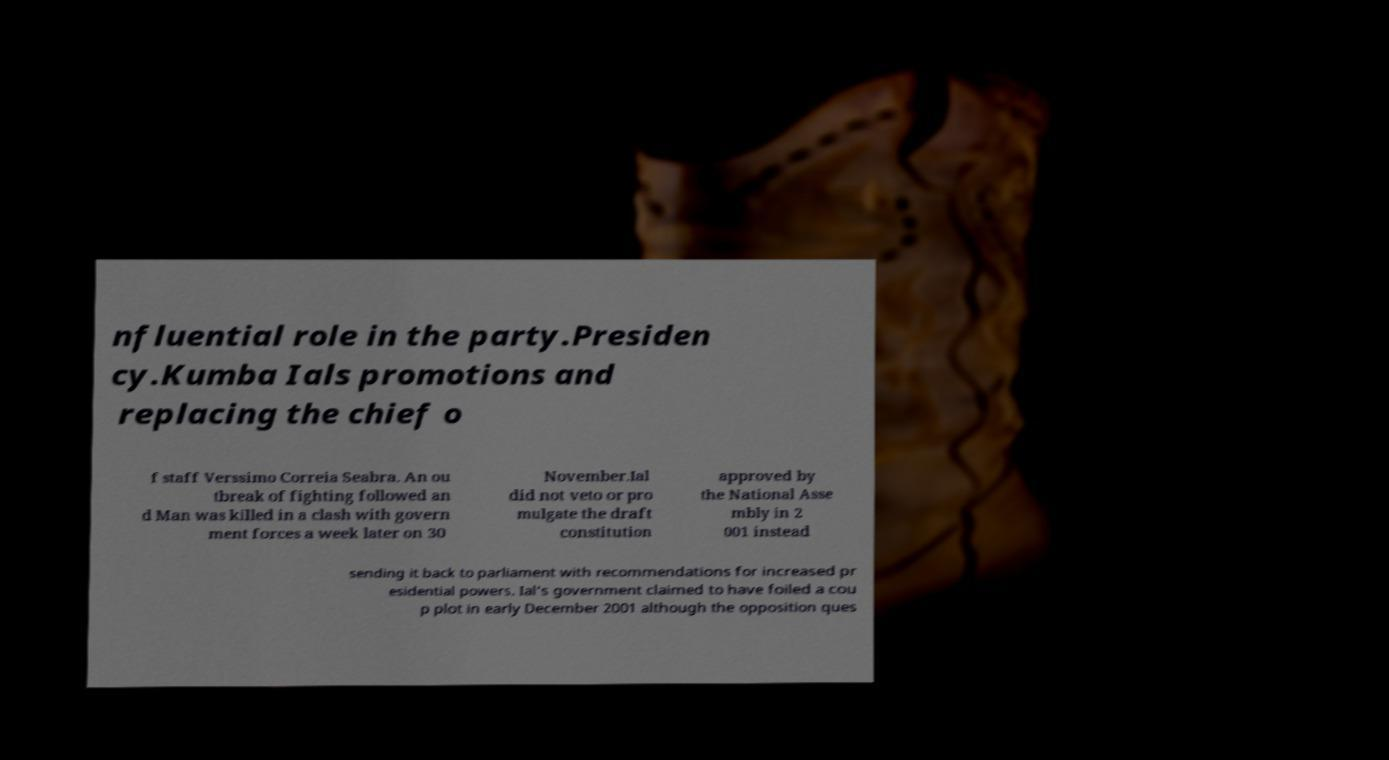What messages or text are displayed in this image? I need them in a readable, typed format. nfluential role in the party.Presiden cy.Kumba Ials promotions and replacing the chief o f staff Verssimo Correia Seabra. An ou tbreak of fighting followed an d Man was killed in a clash with govern ment forces a week later on 30 November.Ial did not veto or pro mulgate the draft constitution approved by the National Asse mbly in 2 001 instead sending it back to parliament with recommendations for increased pr esidential powers. Ial's government claimed to have foiled a cou p plot in early December 2001 although the opposition ques 